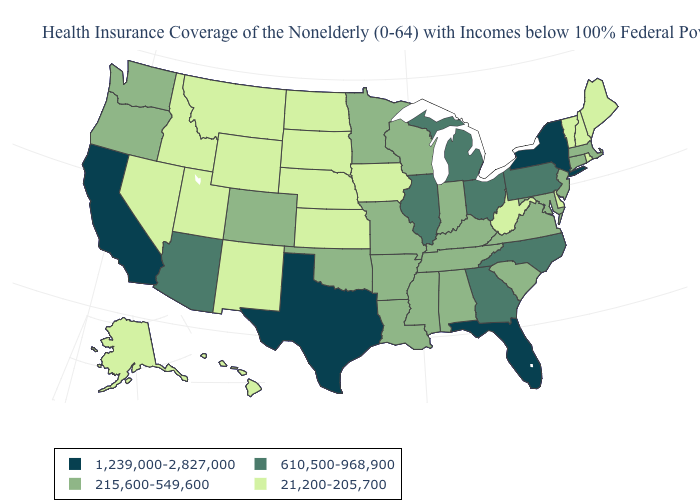What is the lowest value in states that border Massachusetts?
Short answer required. 21,200-205,700. What is the value of Massachusetts?
Give a very brief answer. 215,600-549,600. Does Iowa have the highest value in the MidWest?
Write a very short answer. No. What is the value of Maryland?
Short answer required. 215,600-549,600. Does Indiana have the same value as Oregon?
Short answer required. Yes. Does South Dakota have the lowest value in the MidWest?
Answer briefly. Yes. Name the states that have a value in the range 610,500-968,900?
Give a very brief answer. Arizona, Georgia, Illinois, Michigan, North Carolina, Ohio, Pennsylvania. What is the lowest value in states that border Vermont?
Keep it brief. 21,200-205,700. What is the value of Mississippi?
Answer briefly. 215,600-549,600. Which states hav the highest value in the West?
Concise answer only. California. Name the states that have a value in the range 610,500-968,900?
Keep it brief. Arizona, Georgia, Illinois, Michigan, North Carolina, Ohio, Pennsylvania. Which states hav the highest value in the West?
Be succinct. California. What is the lowest value in the USA?
Quick response, please. 21,200-205,700. What is the value of Mississippi?
Write a very short answer. 215,600-549,600. What is the highest value in the West ?
Short answer required. 1,239,000-2,827,000. 